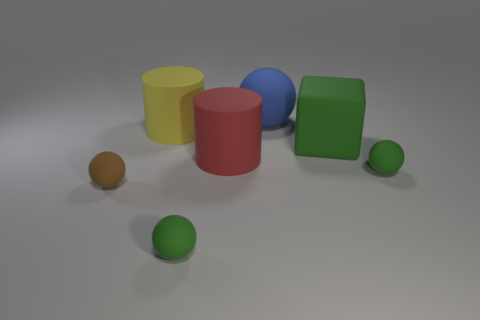What is the shape of the small matte thing that is in front of the tiny brown ball?
Ensure brevity in your answer.  Sphere. The block that is the same size as the blue matte ball is what color?
Your answer should be compact. Green. Is the large green object the same shape as the big red object?
Give a very brief answer. No. The blue ball has what size?
Offer a terse response. Large. The other large matte thing that is the same shape as the large yellow thing is what color?
Your response must be concise. Red. Are there any other things that are the same color as the big matte block?
Ensure brevity in your answer.  Yes. There is a object to the left of the big yellow object; is it the same size as the rubber cylinder right of the yellow matte thing?
Your response must be concise. No. Is the number of big rubber things left of the big rubber sphere the same as the number of big things that are behind the big block?
Make the answer very short. Yes. Does the red cylinder have the same size as the green thing in front of the small brown object?
Keep it short and to the point. No. There is a green ball right of the large blue matte thing; is there a green rubber ball that is on the left side of it?
Your answer should be compact. Yes. 